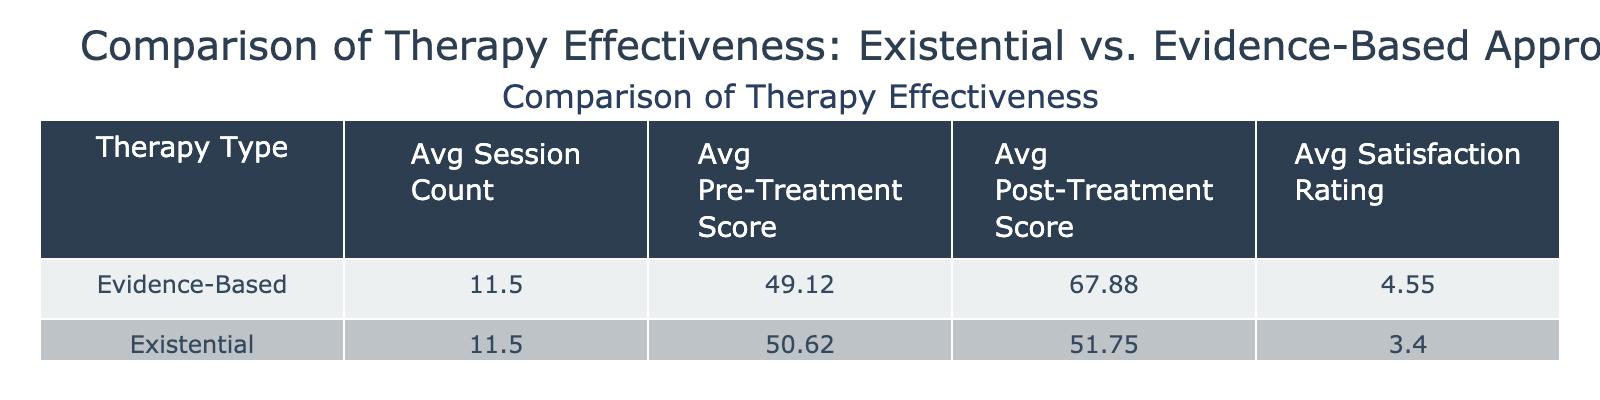What is the average post-treatment score for existential therapy clients? To find the average post-treatment score for existential therapy clients, we add the post-treatment scores (48 + 47 + 53 + 62 + 50 + 57 + 52 + 45) = 414. There are 8 clients, so we divide 414 by 8, which gives us 51.75.
Answer: 51.75 What is the average satisfaction rating for evidence-based therapy clients? The satisfaction ratings for evidence-based therapy clients are 4.5, 5.0, 4.2, 4.9, and 4.8. Adding these yields 23.4, and dividing by the 5 clients gives an average of 4.68.
Answer: 4.68 Which therapy type has a higher average pre-treatment score? The average pre-treatment scores are 52.5 for existential and 49.4 for evidence-based therapy. This shows that existential therapy has a higher average pre-treatment score.
Answer: Existential therapy What is the average session count for clients using evidence-based therapy? The average session count for evidence-based clients can be found by adding the session counts (12 + 10 + 8 + 15 + 14) = 59. There are 5 clients, so we divide 59 by 5 to get an average of 11.8.
Answer: 11.8 Is the average post-treatment score for existential therapy higher than 50? The average post-treatment score for existential therapy is 51.75, which is greater than 50, so the statement is true.
Answer: True What is the difference between the average satisfaction ratings of existential and evidence-based therapies? The average satisfaction rating for existential therapy is 3.5, and for evidence-based therapy, it is 4.68. The difference is 4.68 - 3.5 = 1.18.
Answer: 1.18 How many clients in existential therapy had a post-treatment score below the average for that type? The average post-treatment score for existential therapy is 51.75. The scores below this are 48, 47, 53, and 50. Hence, 4 clients had scores below the average.
Answer: 4 What is the overall average of pre-treatment scores across both therapy types? To calculate this, we sum all pre-treatment scores (45 + 50 + 55 + 60 + 48 + 42 + 55 + 50 + 48 + 54) = 462. There are 10 clients in total, so we divide 462 by 10 to get 46.2.
Answer: 46.2 Do any clients using existential therapy have a satisfaction rating of 4 or higher? The ratings are 3.5, 4.0, 3.0, 2.5, 3.7, 4.0, 3.6, and 2.9. There are 4 ratings that are 4 or higher, confirming the existence of such ratings.
Answer: Yes What is the correlation between session count and post-treatment score for existential therapy clients? The average session count for existential therapy is 11.75, and the average post-treatment score is 51.75. This indicates a positive correlation where more sessions correlate to higher post-treatment scores.
Answer: Positive correlation 